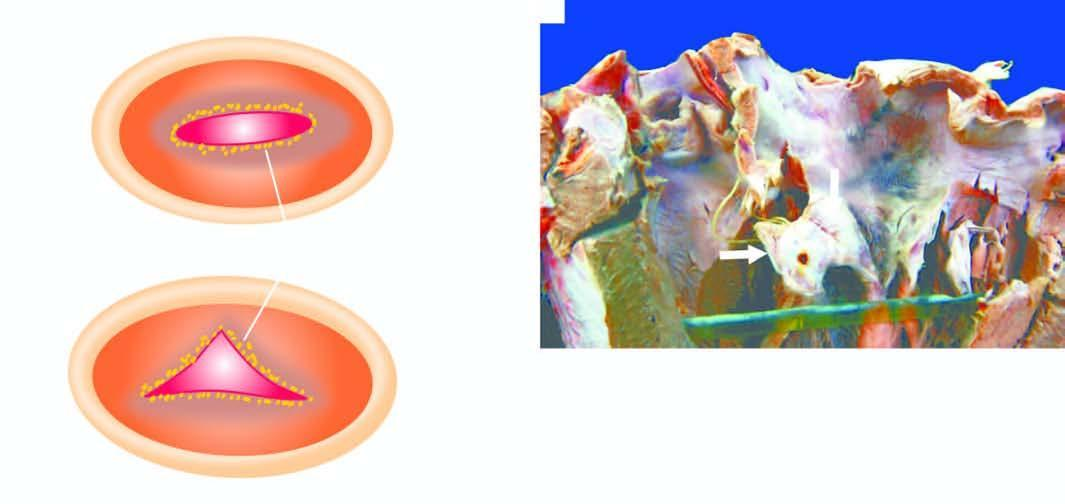re the location of vegetations on mitral valve shown as seen from the left ventricular surface?
Answer the question using a single word or phrase. Yes 